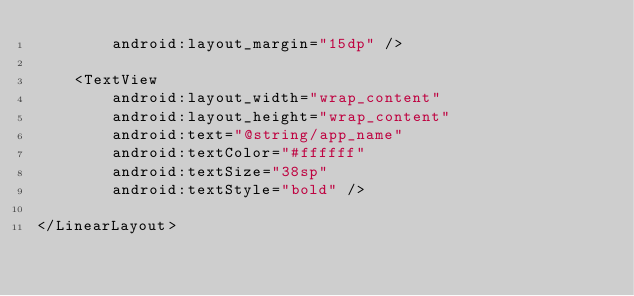<code> <loc_0><loc_0><loc_500><loc_500><_XML_>        android:layout_margin="15dp" />

    <TextView
        android:layout_width="wrap_content"
        android:layout_height="wrap_content"
        android:text="@string/app_name"
        android:textColor="#ffffff"
        android:textSize="38sp"
        android:textStyle="bold" />

</LinearLayout></code> 